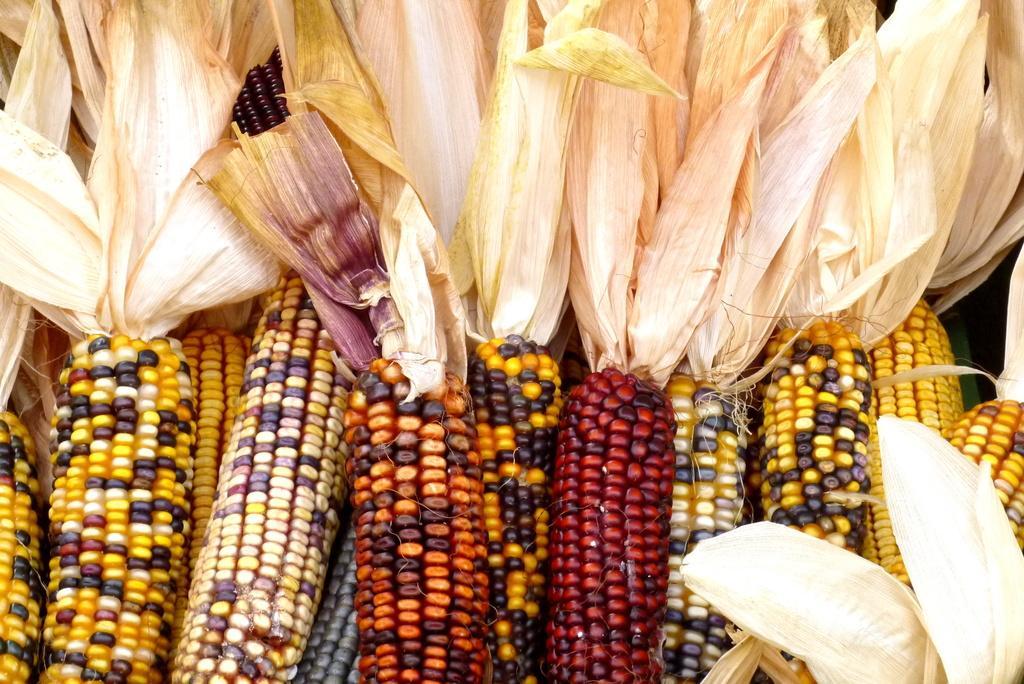Describe this image in one or two sentences. In this picture I can see bunch of maize. 